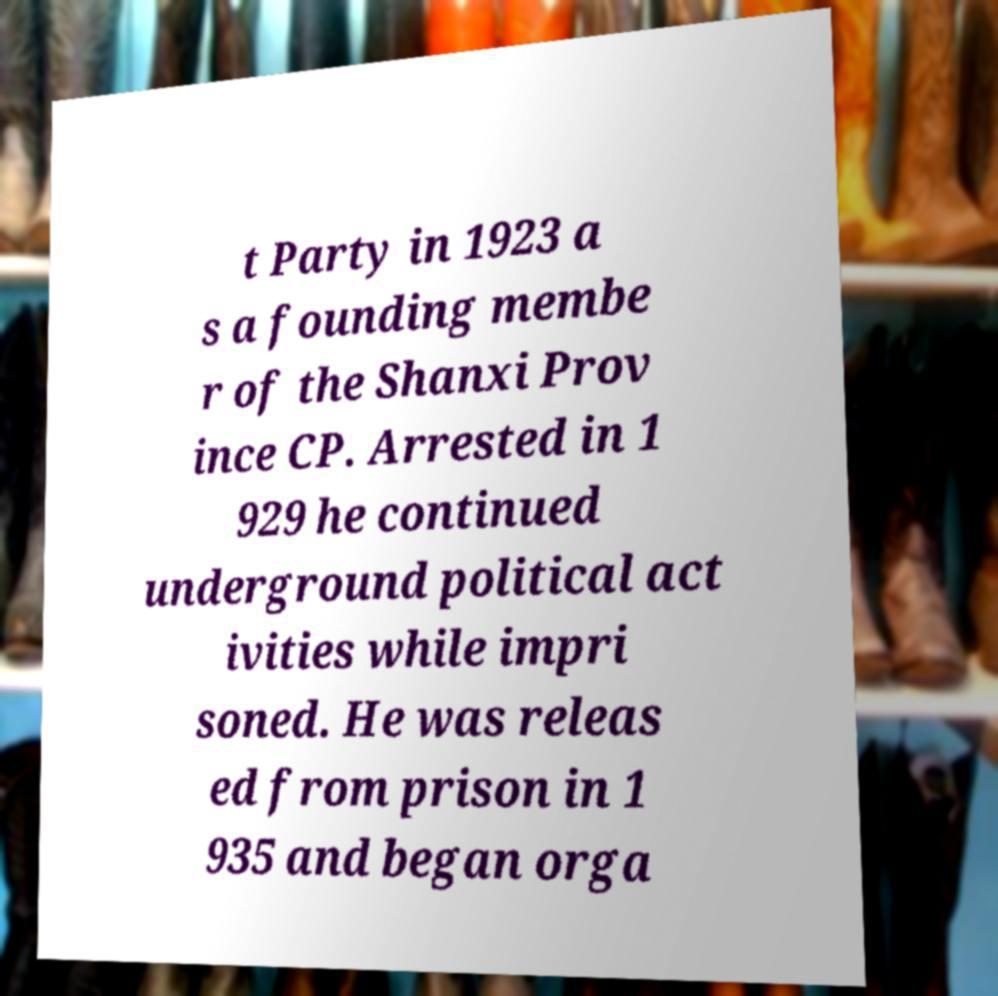What messages or text are displayed in this image? I need them in a readable, typed format. t Party in 1923 a s a founding membe r of the Shanxi Prov ince CP. Arrested in 1 929 he continued underground political act ivities while impri soned. He was releas ed from prison in 1 935 and began orga 